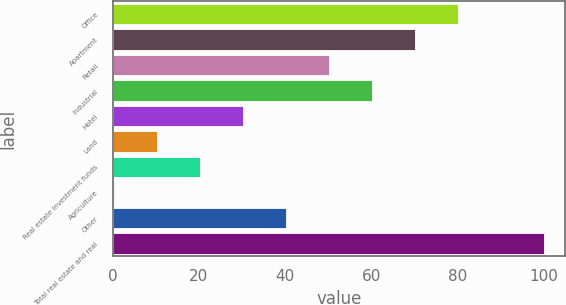<chart> <loc_0><loc_0><loc_500><loc_500><bar_chart><fcel>Office<fcel>Apartment<fcel>Retail<fcel>Industrial<fcel>Hotel<fcel>Land<fcel>Real estate investment funds<fcel>Agriculture<fcel>Other<fcel>Total real estate and real<nl><fcel>80.06<fcel>70.09<fcel>50.15<fcel>60.12<fcel>30.21<fcel>10.27<fcel>20.24<fcel>0.3<fcel>40.18<fcel>100<nl></chart> 